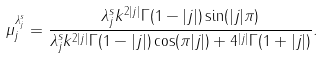<formula> <loc_0><loc_0><loc_500><loc_500>\mu _ { j } ^ { \lambda _ { j } ^ { s } } = \frac { \lambda _ { j } ^ { s } k ^ { 2 | j | } \Gamma ( 1 - | j | ) \sin ( | j | \pi ) } { \lambda _ { j } ^ { s } k ^ { 2 | j | } \Gamma { ( 1 - | j | ) } \cos ( \pi | j | ) + 4 ^ { | j | } \Gamma ( 1 + | j | ) } .</formula> 